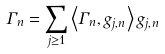Convert formula to latex. <formula><loc_0><loc_0><loc_500><loc_500>\Gamma _ { n } = \sum _ { j \geq 1 } \left \langle \Gamma _ { n } , g _ { j , n } \right \rangle g _ { j , n }</formula> 